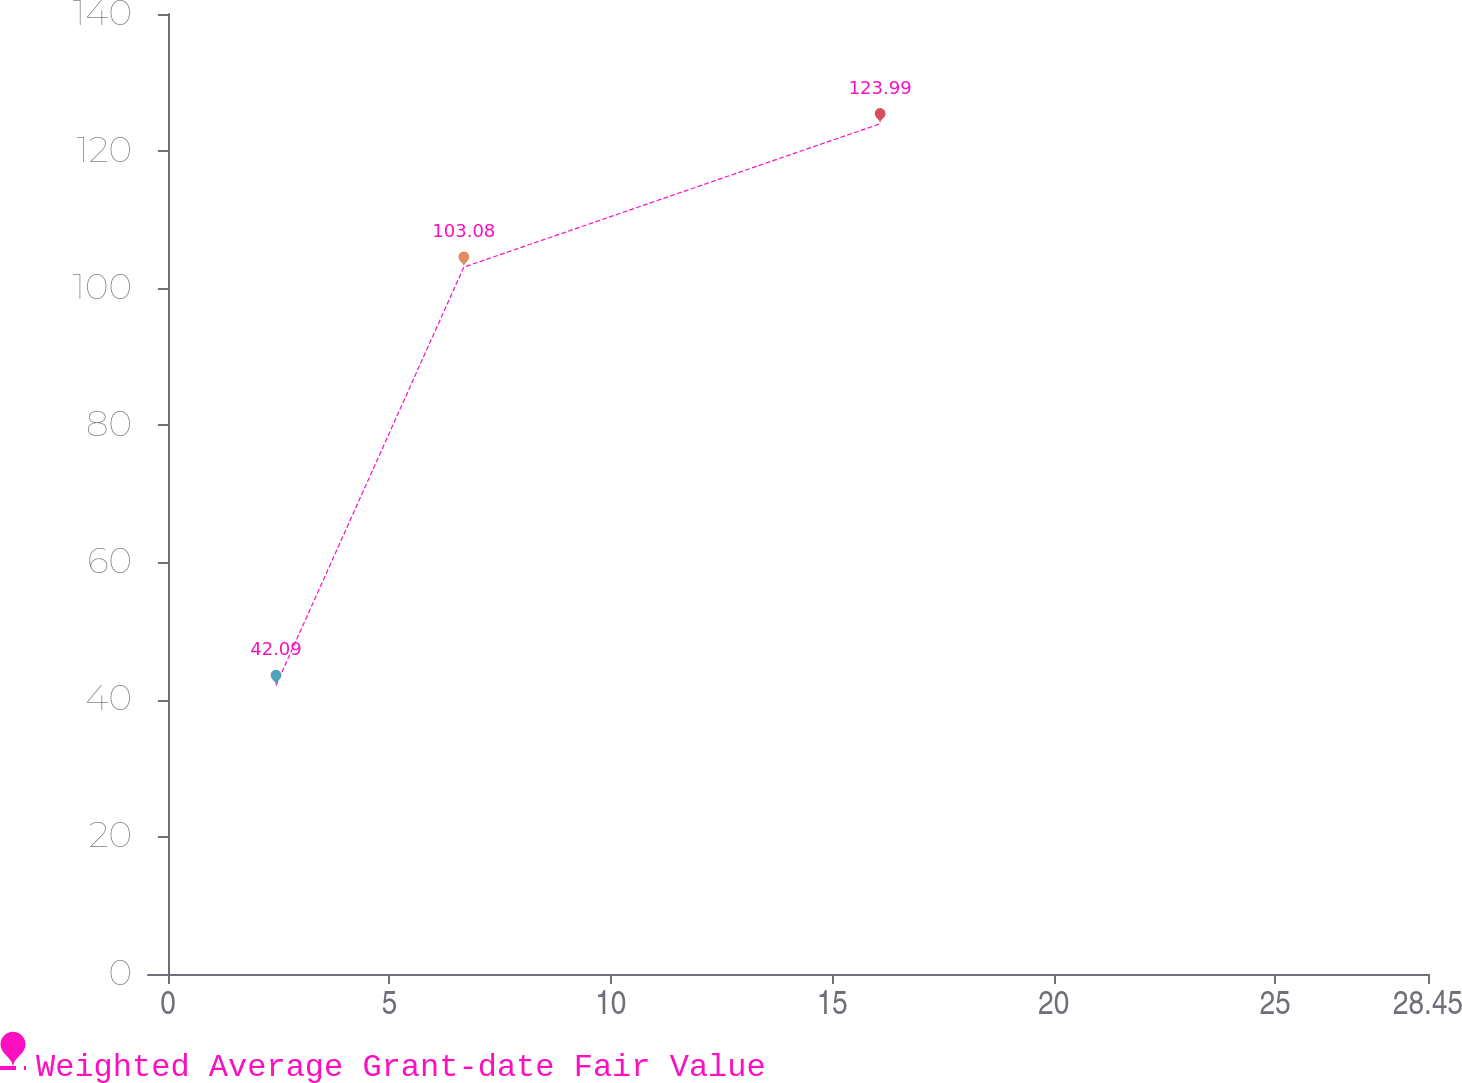Convert chart. <chart><loc_0><loc_0><loc_500><loc_500><line_chart><ecel><fcel>Weighted Average Grant-date Fair Value<nl><fcel>2.44<fcel>42.09<nl><fcel>6.68<fcel>103.08<nl><fcel>16.08<fcel>123.99<nl><fcel>31.34<fcel>65.32<nl></chart> 